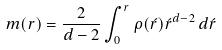<formula> <loc_0><loc_0><loc_500><loc_500>m ( r ) = \frac { 2 } { d - 2 } \int _ { 0 } ^ { r } \rho ( \acute { r } ) \acute { r } ^ { d - 2 } \, d \acute { r }</formula> 